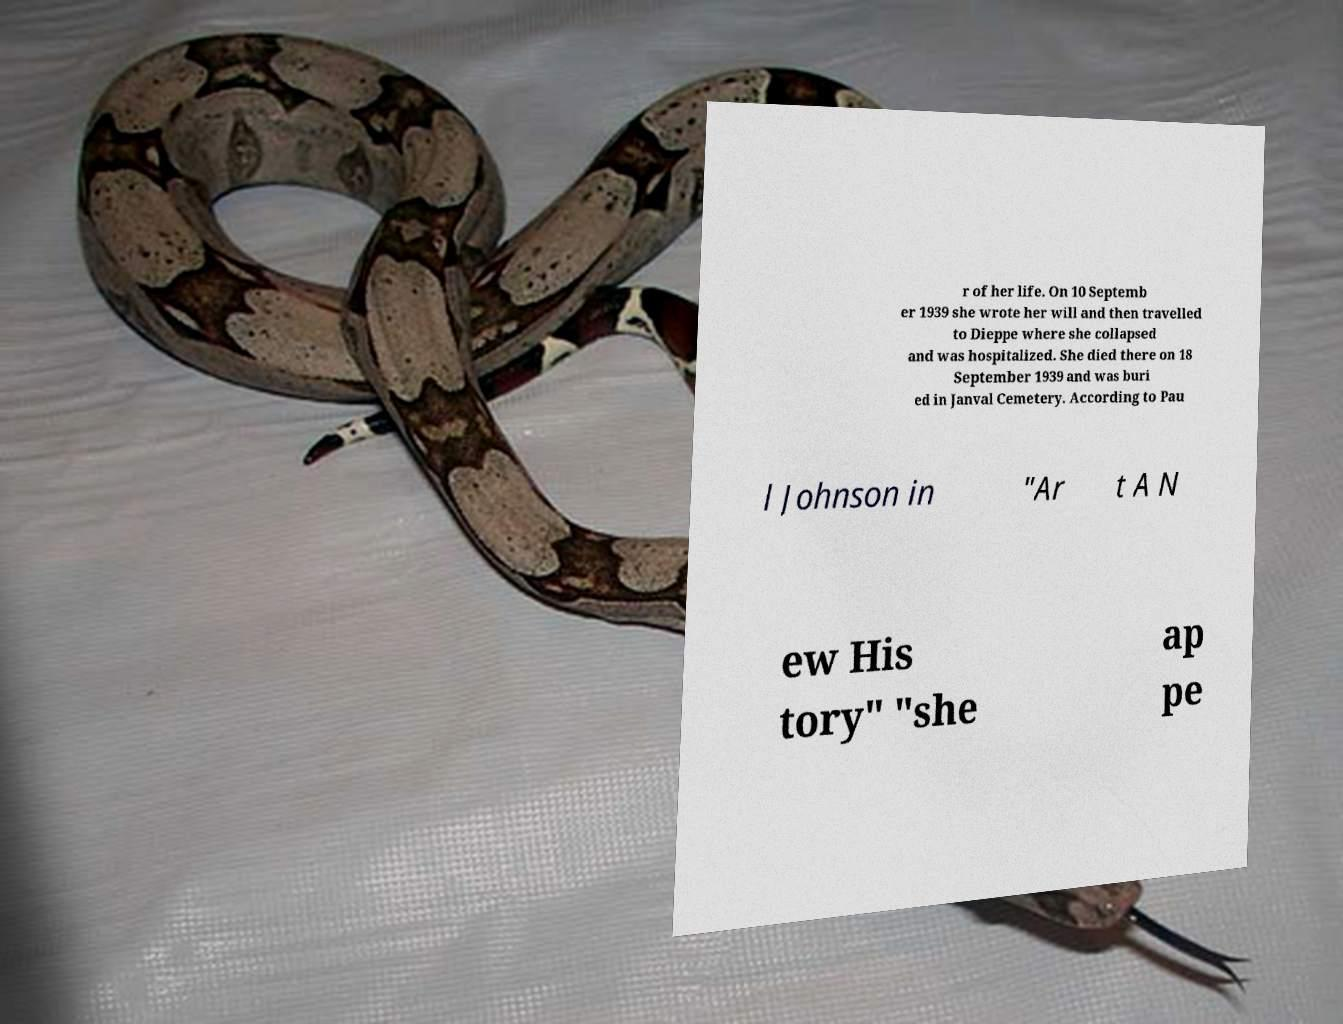Can you read and provide the text displayed in the image?This photo seems to have some interesting text. Can you extract and type it out for me? r of her life. On 10 Septemb er 1939 she wrote her will and then travelled to Dieppe where she collapsed and was hospitalized. She died there on 18 September 1939 and was buri ed in Janval Cemetery. According to Pau l Johnson in "Ar t A N ew His tory" "she ap pe 